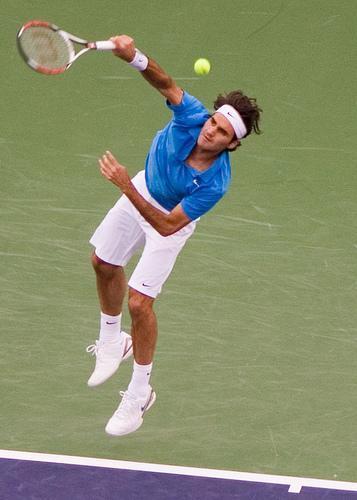How many balls are there?
Give a very brief answer. 1. 